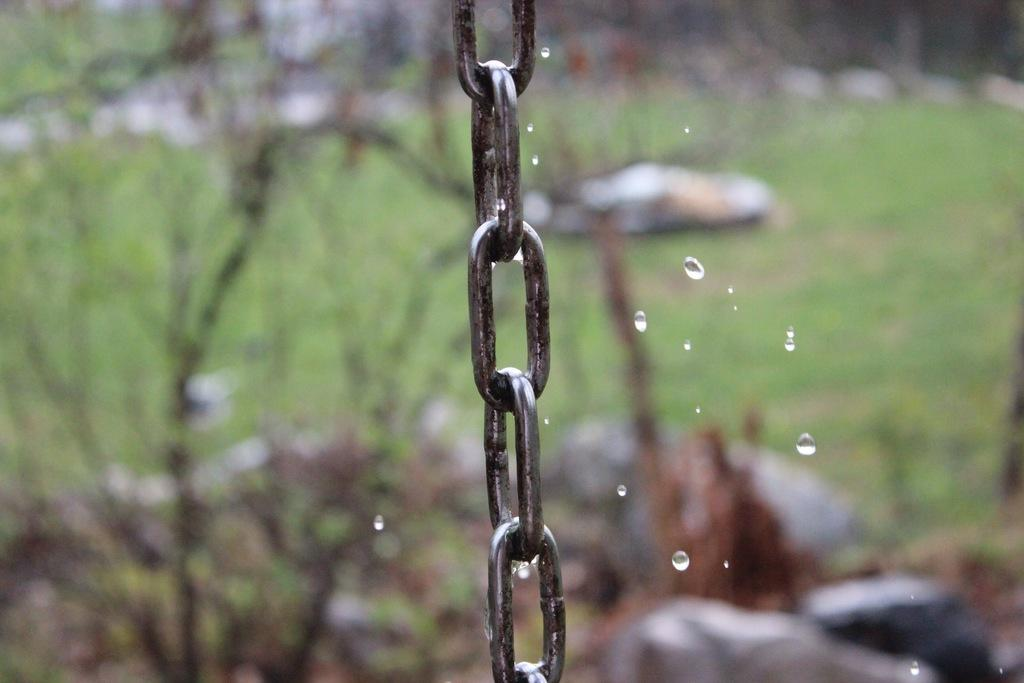What is the main object in the image? There is a chain in the image. What can be seen on the chain? Water droplets are visible on the chain in the image. What type of environment is depicted in the image? There is grass in the image, suggesting an outdoor setting. What level of experience does the plastic have in the image? There is no plastic present in the image, so it is not possible to determine the level of experience it might have. 